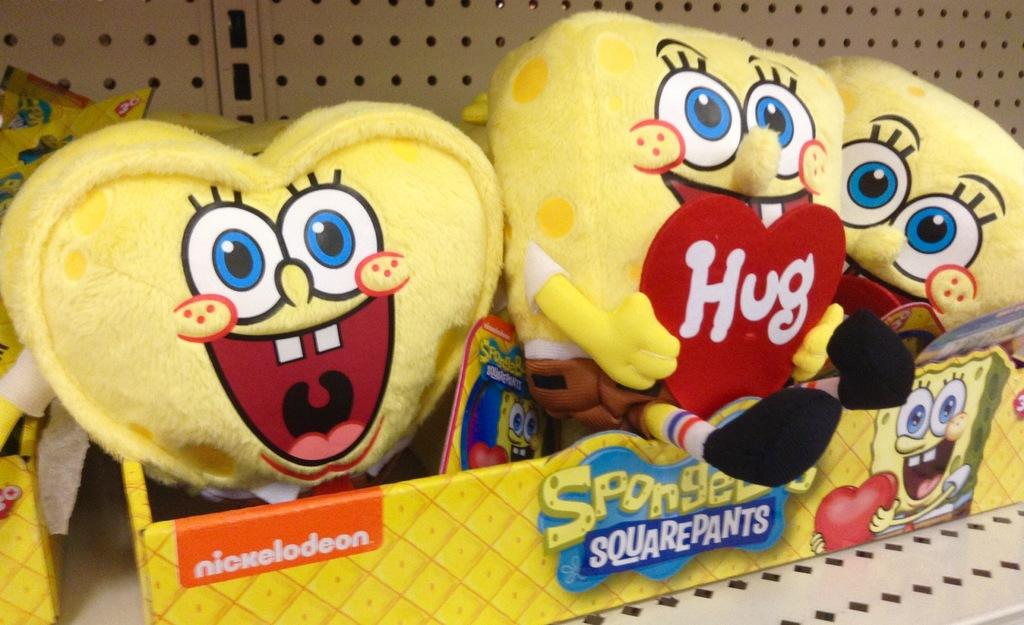What color are the dolls in the box in the image? The dolls in the box are yellow in color. What is the color of the box containing the dolls? The box is also yellow in color. Where is the box with the dolls located? The box is on a table. Are there any other boxes in the image? Yes, there is another box near the first box. What is in the second box? The second box also contains yellow color dolls. What can be seen on the wall in the image? There is a white wall in the image. What type of ant can be seen leading the dolls on a voyage in the image? There are no ants or voyages depicted in the image; it features yellow dolls in a yellow box on a table. 